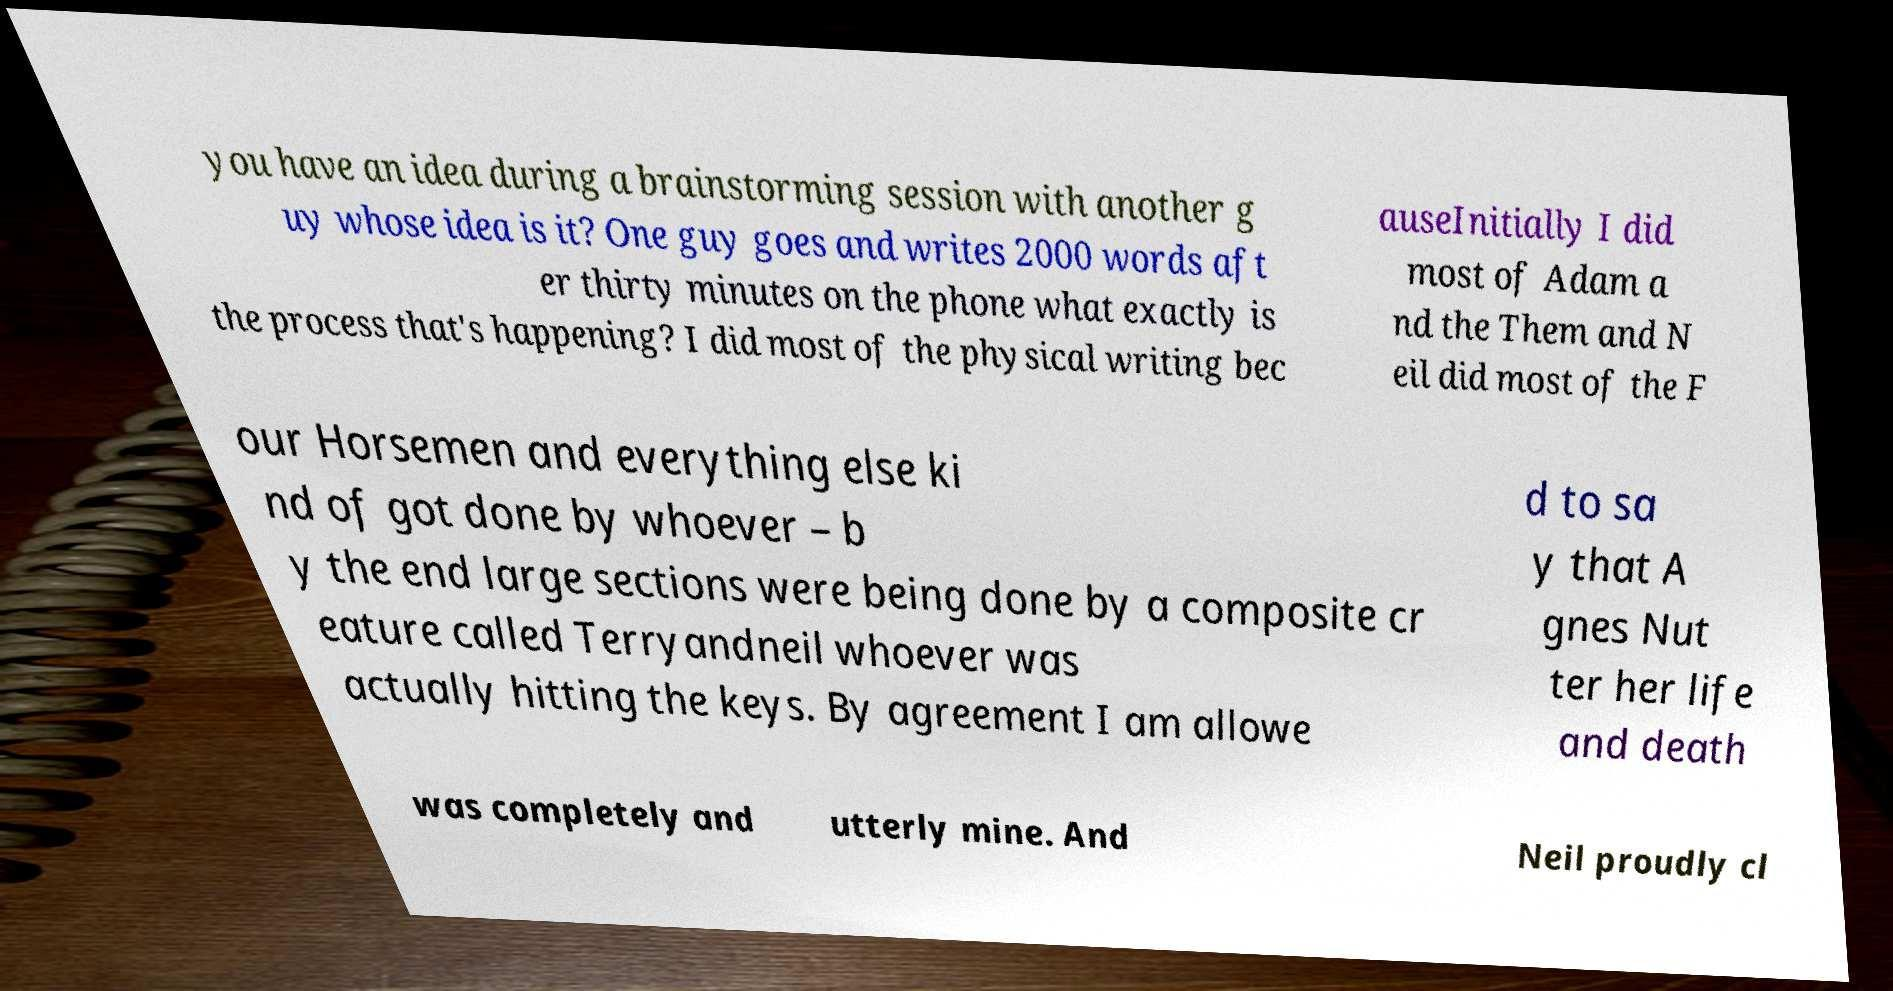Could you extract and type out the text from this image? you have an idea during a brainstorming session with another g uy whose idea is it? One guy goes and writes 2000 words aft er thirty minutes on the phone what exactly is the process that's happening? I did most of the physical writing bec auseInitially I did most of Adam a nd the Them and N eil did most of the F our Horsemen and everything else ki nd of got done by whoever – b y the end large sections were being done by a composite cr eature called Terryandneil whoever was actually hitting the keys. By agreement I am allowe d to sa y that A gnes Nut ter her life and death was completely and utterly mine. And Neil proudly cl 